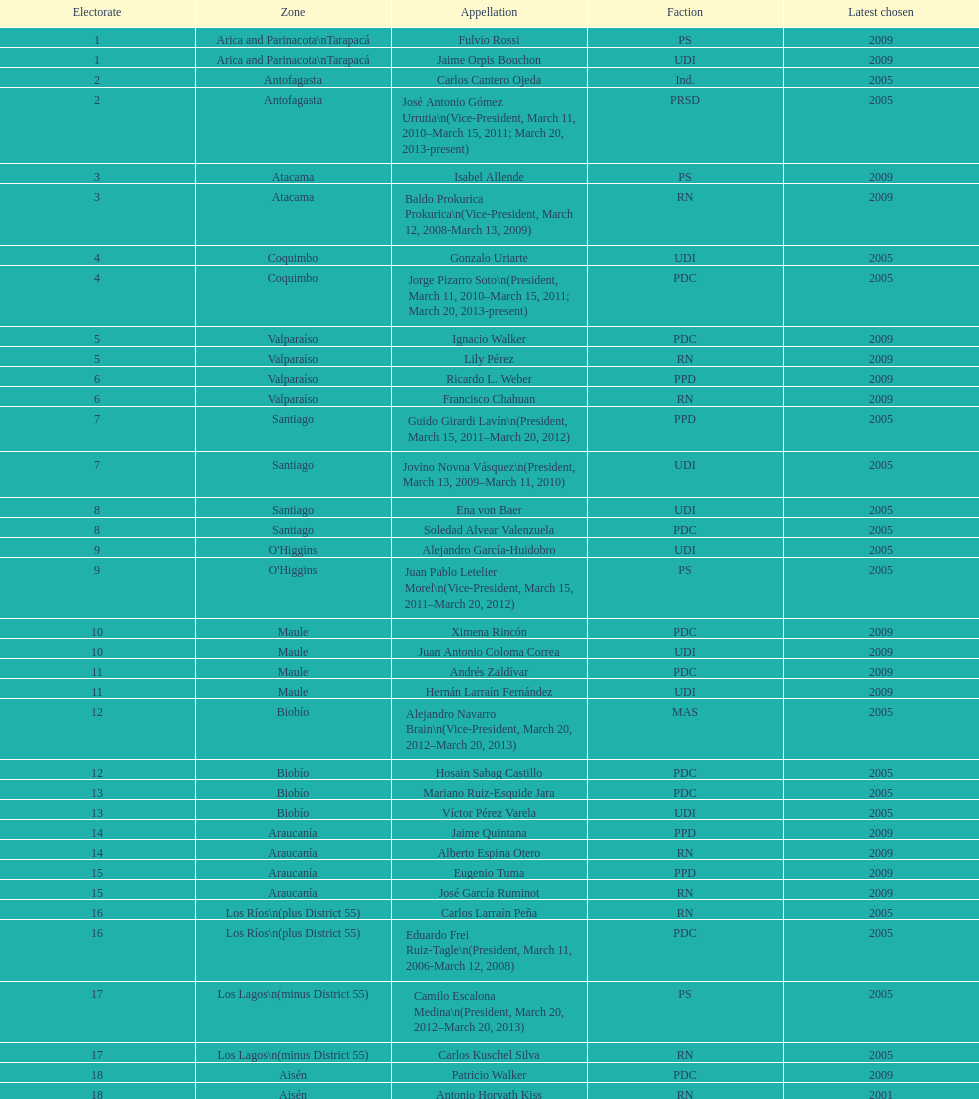Which area is mentioned below atacama? Coquimbo. 